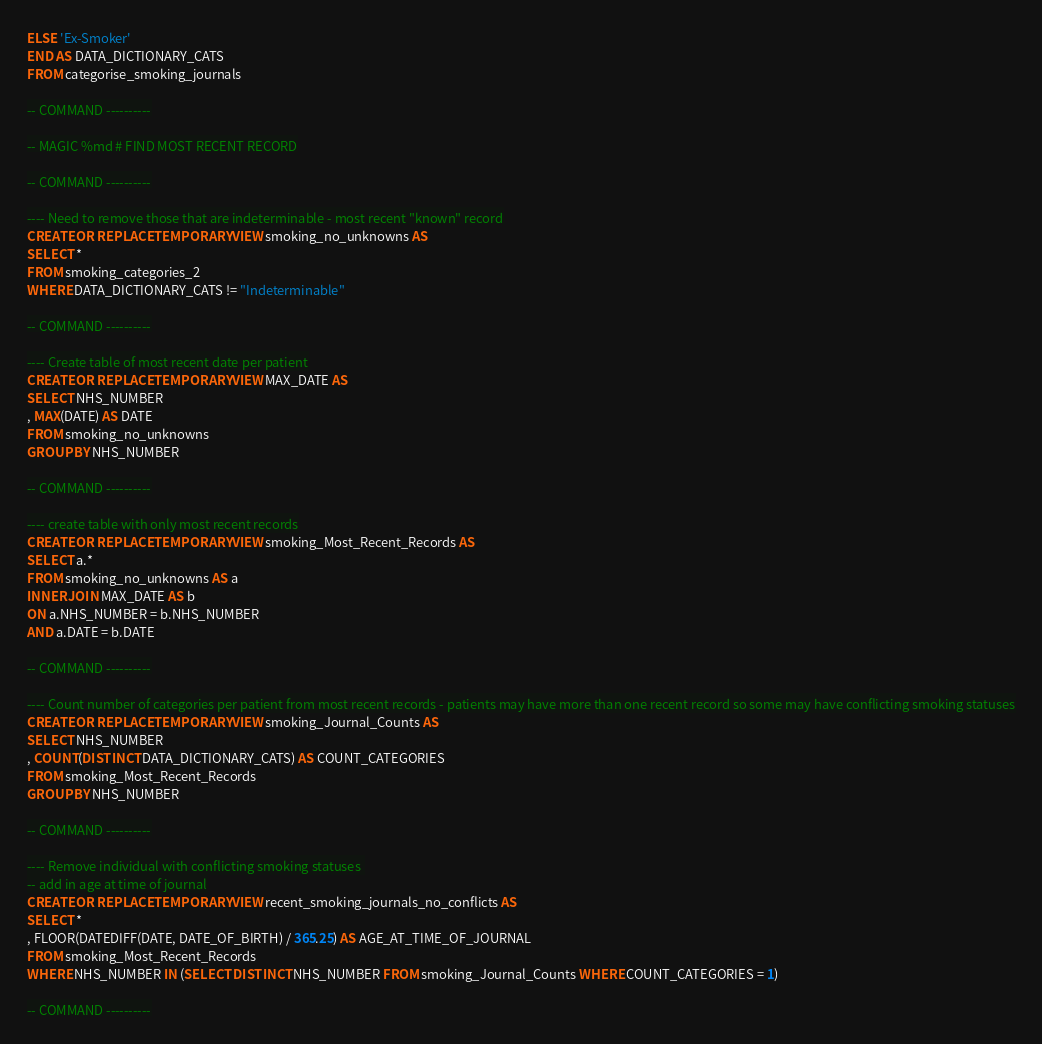<code> <loc_0><loc_0><loc_500><loc_500><_SQL_>ELSE 'Ex-Smoker'
END AS DATA_DICTIONARY_CATS
FROM categorise_smoking_journals

-- COMMAND ----------

-- MAGIC %md # FIND MOST RECENT RECORD

-- COMMAND ----------

---- Need to remove those that are indeterminable - most recent "known" record
CREATE OR REPLACE TEMPORARY VIEW smoking_no_unknowns AS
SELECT * 
FROM smoking_categories_2
WHERE DATA_DICTIONARY_CATS != "Indeterminable"

-- COMMAND ----------

---- Create table of most recent date per patient
CREATE OR REPLACE TEMPORARY VIEW MAX_DATE AS
SELECT NHS_NUMBER
, MAX(DATE) AS DATE
FROM smoking_no_unknowns
GROUP BY NHS_NUMBER

-- COMMAND ----------

---- create table with only most recent records
CREATE OR REPLACE TEMPORARY VIEW smoking_Most_Recent_Records AS
SELECT a.*
FROM smoking_no_unknowns AS a
INNER JOIN MAX_DATE AS b
ON a.NHS_NUMBER = b.NHS_NUMBER
AND a.DATE = b.DATE

-- COMMAND ----------

---- Count number of categories per patient from most recent records - patients may have more than one recent record so some may have conflicting smoking statuses
CREATE OR REPLACE TEMPORARY VIEW smoking_Journal_Counts AS
SELECT NHS_NUMBER
, COUNT(DISTINCT DATA_DICTIONARY_CATS) AS COUNT_CATEGORIES
FROM smoking_Most_Recent_Records
GROUP BY NHS_NUMBER

-- COMMAND ----------

---- Remove individual with conflicting smoking statuses 
-- add in age at time of journal
CREATE OR REPLACE TEMPORARY VIEW recent_smoking_journals_no_conflicts AS
SELECT * 
, FLOOR(DATEDIFF(DATE, DATE_OF_BIRTH) / 365.25) AS AGE_AT_TIME_OF_JOURNAL
FROM smoking_Most_Recent_Records
WHERE NHS_NUMBER IN (SELECT DISTINCT NHS_NUMBER FROM smoking_Journal_Counts WHERE COUNT_CATEGORIES = 1)

-- COMMAND ----------</code> 